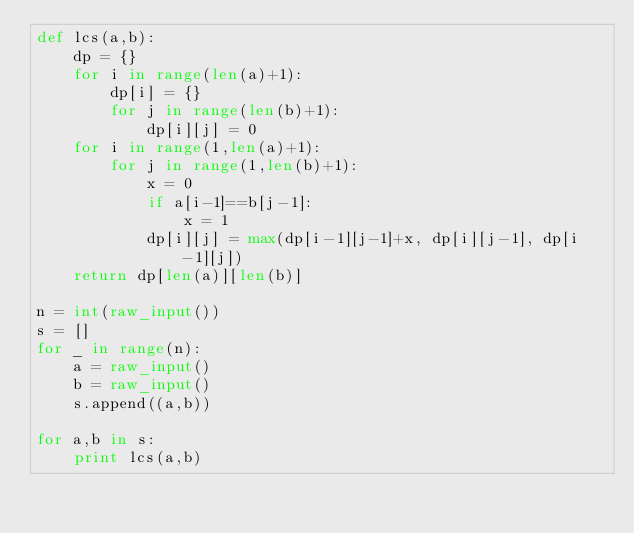Convert code to text. <code><loc_0><loc_0><loc_500><loc_500><_Python_>def lcs(a,b):
    dp = {}
    for i in range(len(a)+1):
        dp[i] = {}
        for j in range(len(b)+1):
            dp[i][j] = 0
    for i in range(1,len(a)+1):
        for j in range(1,len(b)+1):
            x = 0
            if a[i-1]==b[j-1]:
                x = 1
            dp[i][j] = max(dp[i-1][j-1]+x, dp[i][j-1], dp[i-1][j])
    return dp[len(a)][len(b)]

n = int(raw_input())
s = []
for _ in range(n):
    a = raw_input()
    b = raw_input()
    s.append((a,b))

for a,b in s:
    print lcs(a,b)</code> 